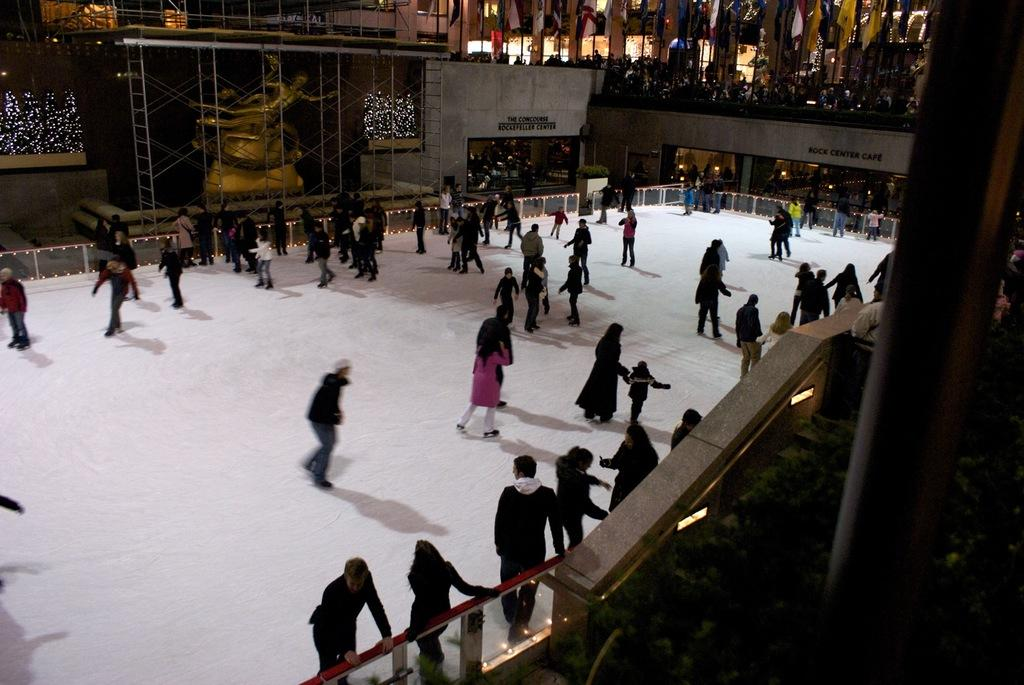Who is present in the image? There are people in the image. What activity are the people engaged in? The people are snow skating. Where is the snow skating taking place? The snow skating is taking place on snow. Can you describe the location of the snow? The snow is in the middle of a building. What is the chance of finding a camp in the image? There is no mention of a camp in the image, so it cannot be determined if there is a chance of finding one. 